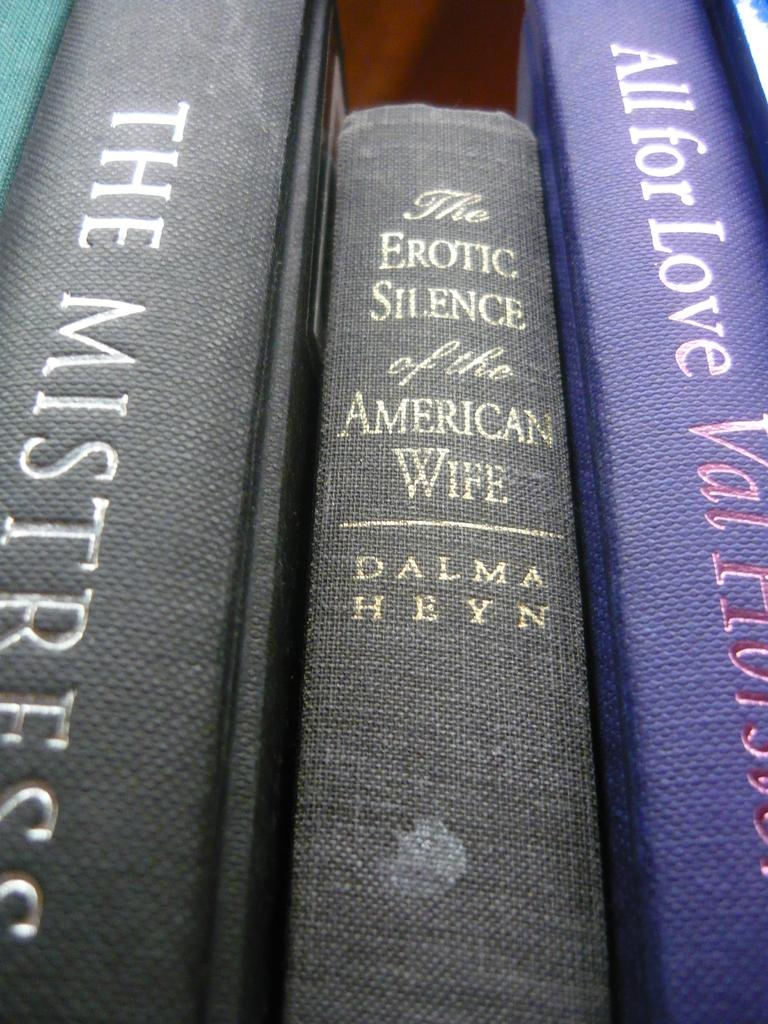<image>
Write a terse but informative summary of the picture. The Erotic Silence of the American Wife sits next to a Mistress book. 